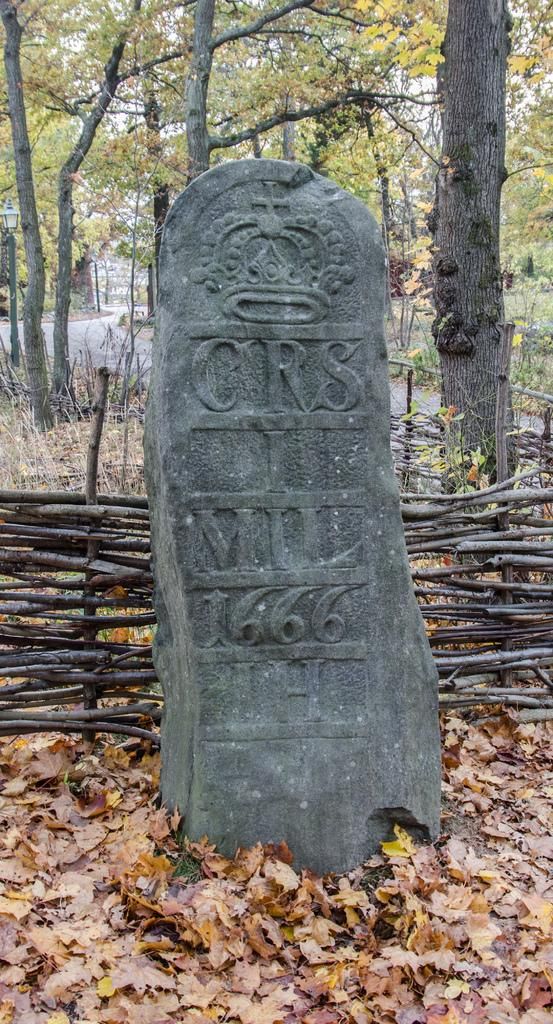What type of material is the laid stone made of in the image? The laid stone in the image is made of stone. What can be found on the ground near the stone? Shredded leaves are present on the ground. What type of barrier is visible in the image? There is a wooden fence in the image. What type of vegetation is visible in the image? Trees are visible in the image. What type of pathway is present in the image? There is a road in the image. What part of the natural environment is visible in the image? The sky is visible in the image. How far away is the aunt's house from the stone in the image? There is no mention of an aunt or a house in the image, so it is impossible to determine the distance. What type of paper is scattered on the ground in the image? There is no paper present in the image; only shredded leaves are visible on the ground. 